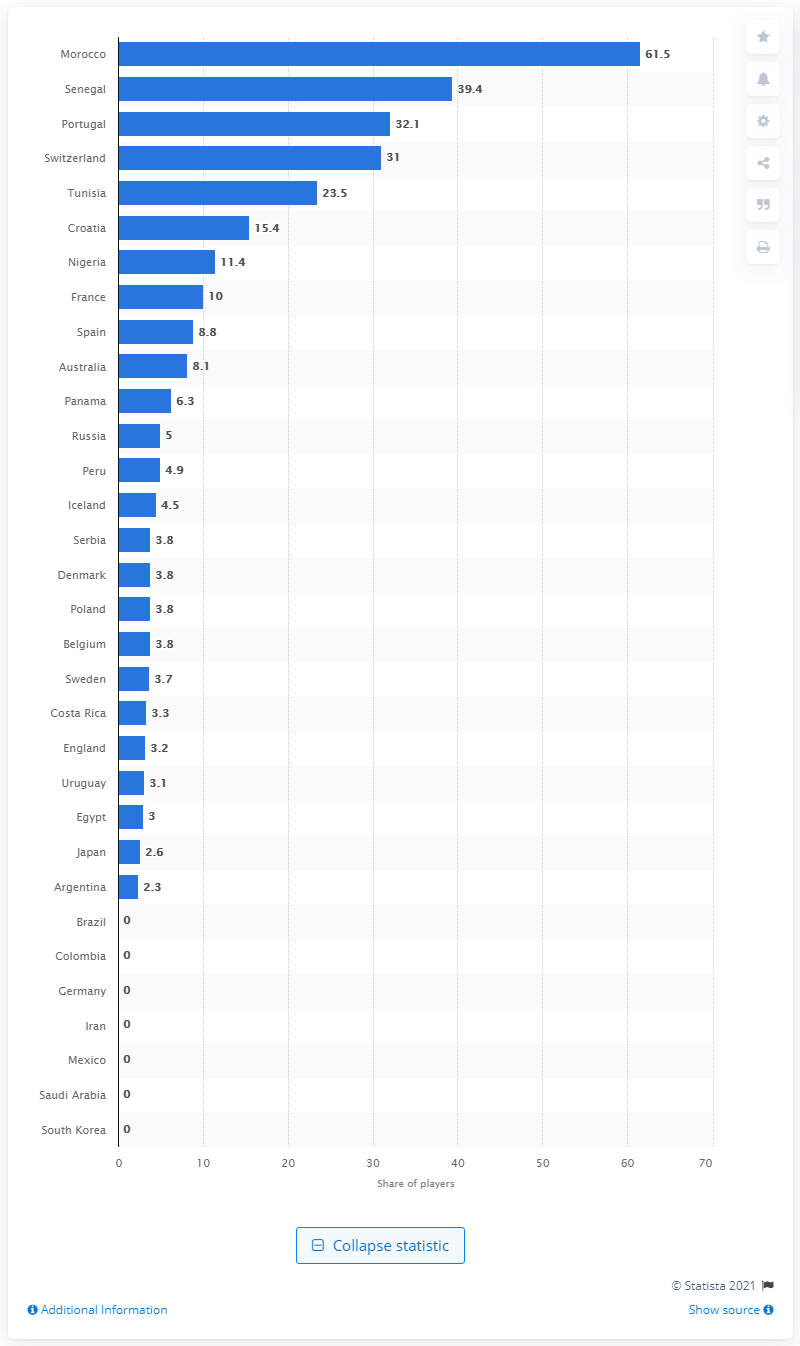Mention a couple of crucial points in this snapshot. The 2018 FIFA World Cup took place in Russia. According to the information provided, 61.5% of the Moroccan soccer squad were born outside of Morocco. 